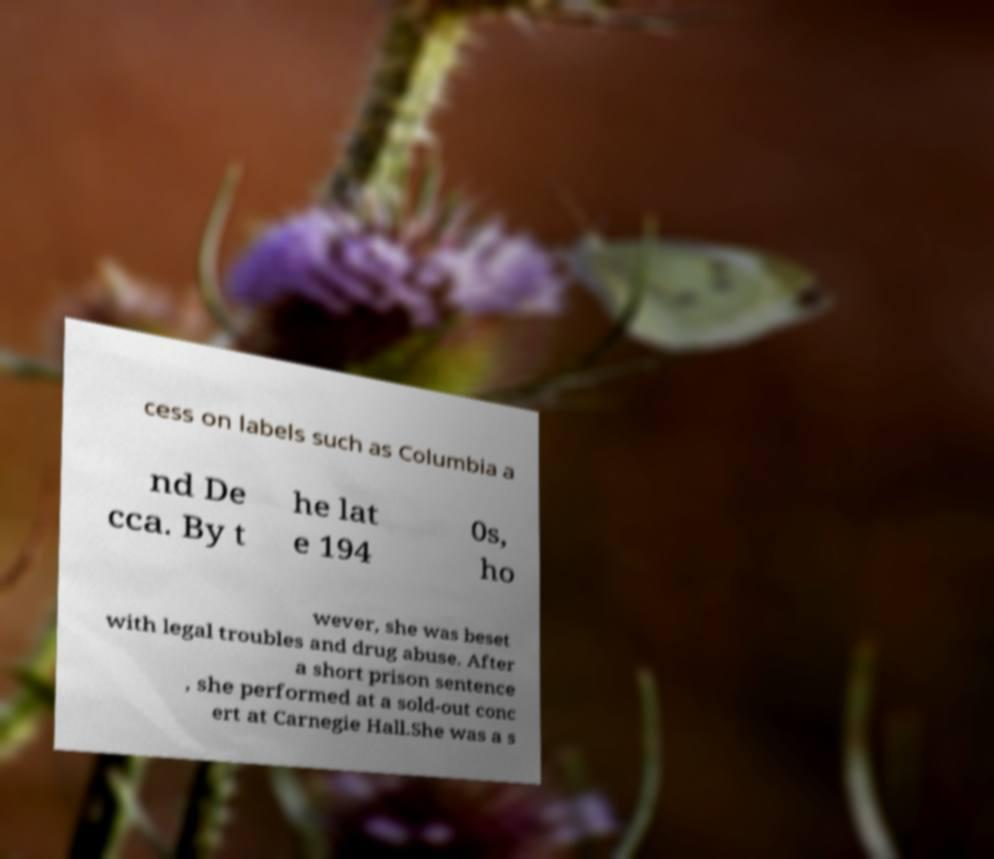Can you read and provide the text displayed in the image?This photo seems to have some interesting text. Can you extract and type it out for me? cess on labels such as Columbia a nd De cca. By t he lat e 194 0s, ho wever, she was beset with legal troubles and drug abuse. After a short prison sentence , she performed at a sold-out conc ert at Carnegie Hall.She was a s 